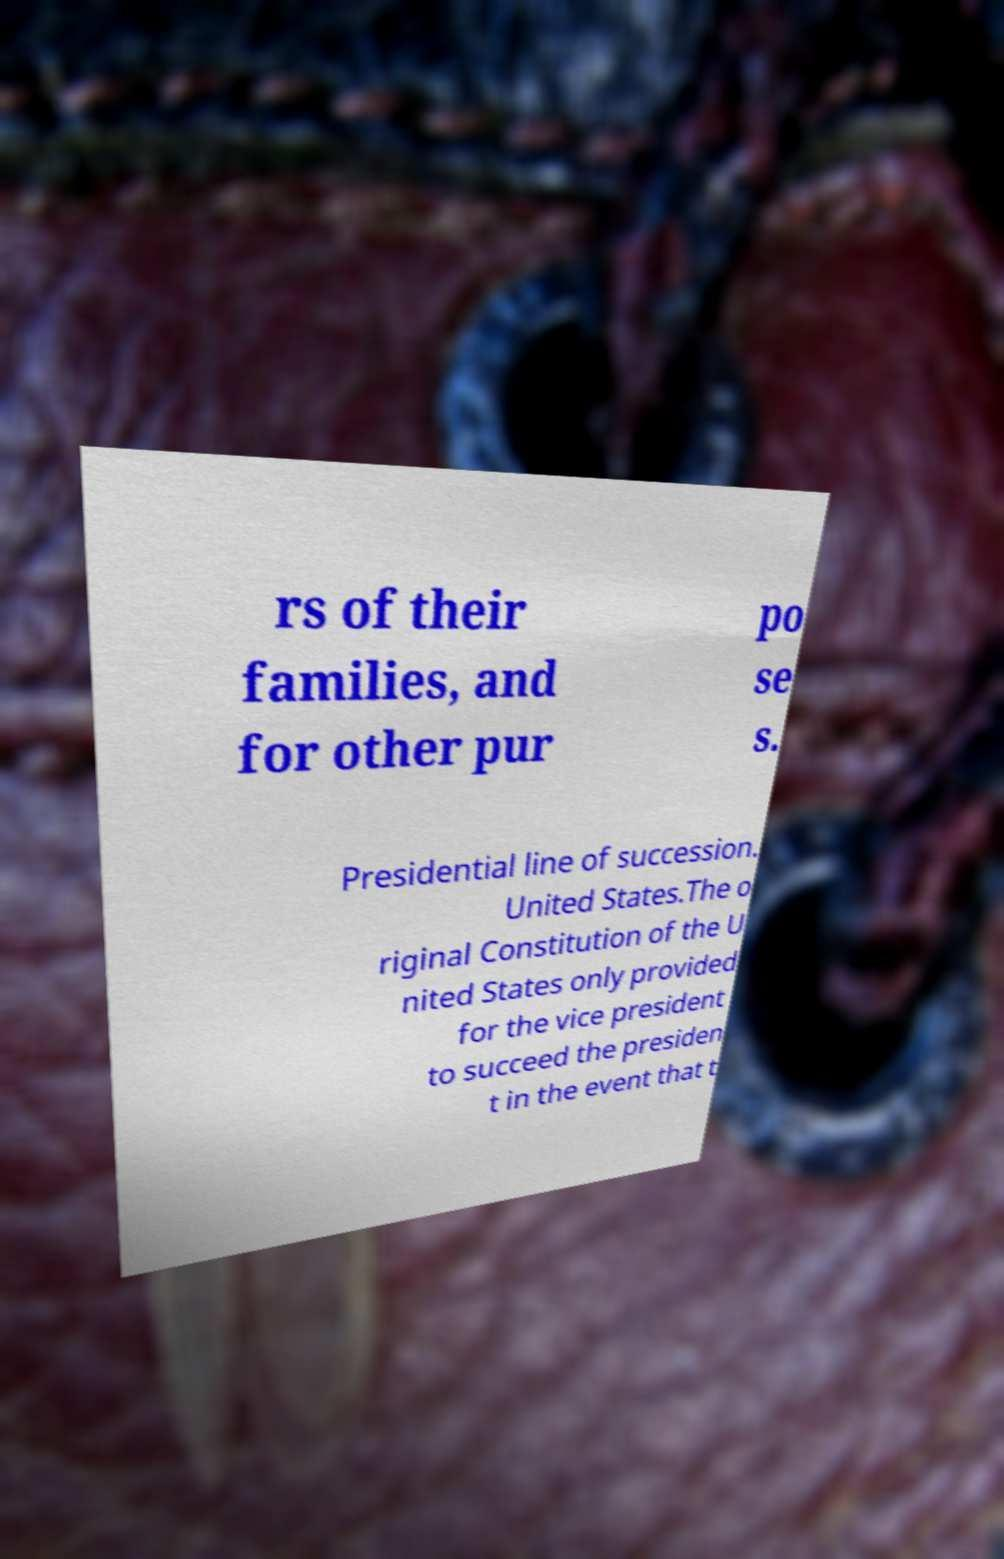For documentation purposes, I need the text within this image transcribed. Could you provide that? rs of their families, and for other pur po se s. Presidential line of succession. United States.The o riginal Constitution of the U nited States only provided for the vice president to succeed the presiden t in the event that t 